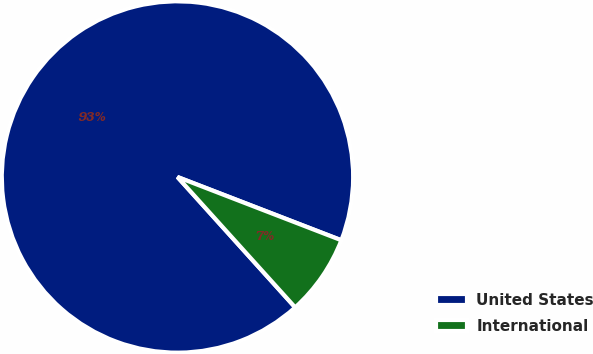Convert chart. <chart><loc_0><loc_0><loc_500><loc_500><pie_chart><fcel>United States<fcel>International<nl><fcel>92.55%<fcel>7.45%<nl></chart> 